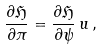<formula> <loc_0><loc_0><loc_500><loc_500>\frac { \partial \mathfrak H } { \partial \pi } = \frac { \partial \mathfrak H } { \partial \psi } \, u \, ,</formula> 